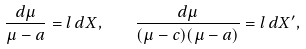Convert formula to latex. <formula><loc_0><loc_0><loc_500><loc_500>\frac { d \mu } { \mu - a } = l \, d X , \quad \frac { d \mu } { ( \mu - c ) ( \mu - a ) } = l \, d X ^ { \prime } ,</formula> 